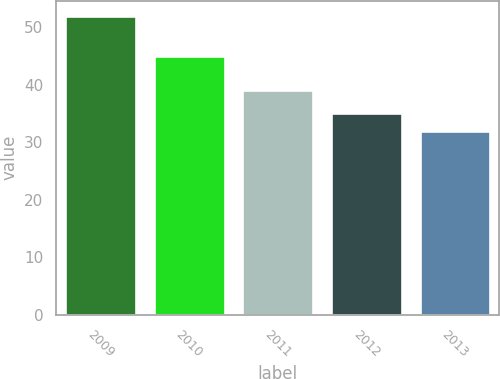<chart> <loc_0><loc_0><loc_500><loc_500><bar_chart><fcel>2009<fcel>2010<fcel>2011<fcel>2012<fcel>2013<nl><fcel>52<fcel>45<fcel>39<fcel>35<fcel>32<nl></chart> 